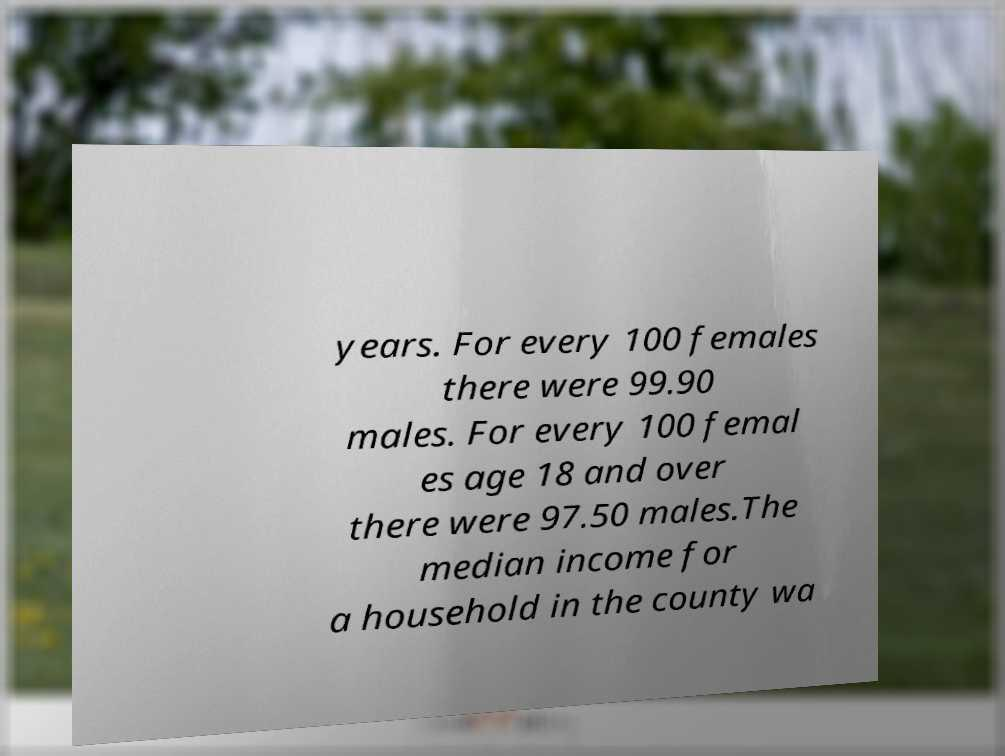Please identify and transcribe the text found in this image. years. For every 100 females there were 99.90 males. For every 100 femal es age 18 and over there were 97.50 males.The median income for a household in the county wa 